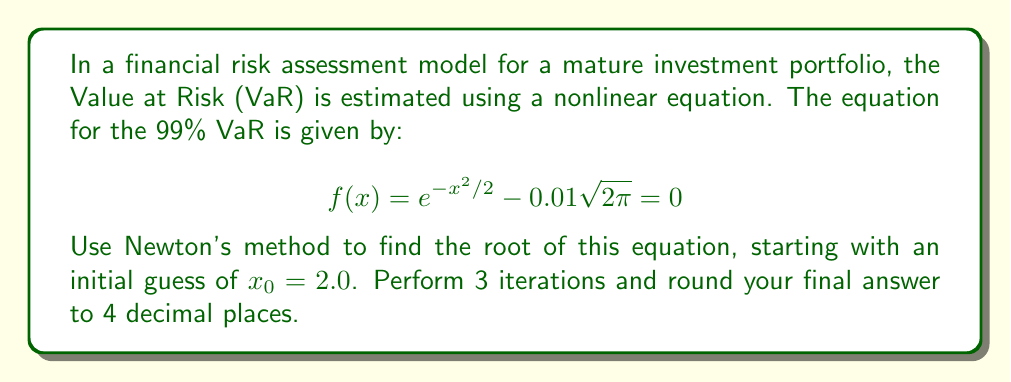Can you solve this math problem? Newton's method for finding roots of nonlinear equations is given by the formula:

$$ x_{n+1} = x_n - \frac{f(x_n)}{f'(x_n)} $$

For our equation $f(x) = e^{-x^2/2} - 0.01\sqrt{2\pi}$, we need to find $f'(x)$:

$$ f'(x) = -xe^{-x^2/2} $$

Now, let's perform 3 iterations:

Iteration 1:
$$ x_1 = 2.0 - \frac{e^{-2.0^2/2} - 0.01\sqrt{2\pi}}{-2.0e^{-2.0^2/2}} = 2.3263 $$

Iteration 2:
$$ x_2 = 2.3263 - \frac{e^{-2.3263^2/2} - 0.01\sqrt{2\pi}}{-2.3263e^{-2.3263^2/2}} = 2.3268 $$

Iteration 3:
$$ x_3 = 2.3268 - \frac{e^{-2.3268^2/2} - 0.01\sqrt{2\pi}}{-2.3268e^{-2.3268^2/2}} = 2.3268 $$

Rounding to 4 decimal places, we get 2.3268.
Answer: 2.3268 